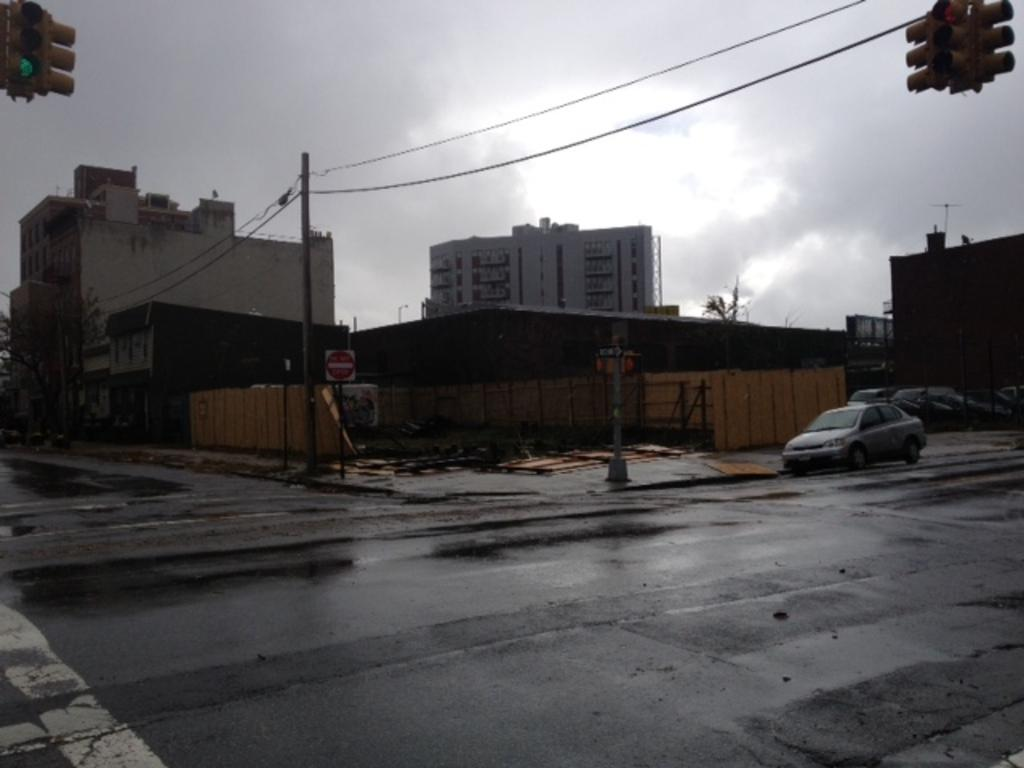What is the main subject of the image? There is a car on the road in the image. What is the condition of the road? The road appears to be wet in the image. What can be seen in the background of the image? There are buildings, a pole with wires, traffic lights, and a board visible in the background. How would you describe the weather in the image? The sky is cloudy in the image. Can you see a nest in the image? There is no nest present in the image. What color is the wrist of the person driving the car? There is no person driving the car visible in the image, and therefore no wrist to describe. 